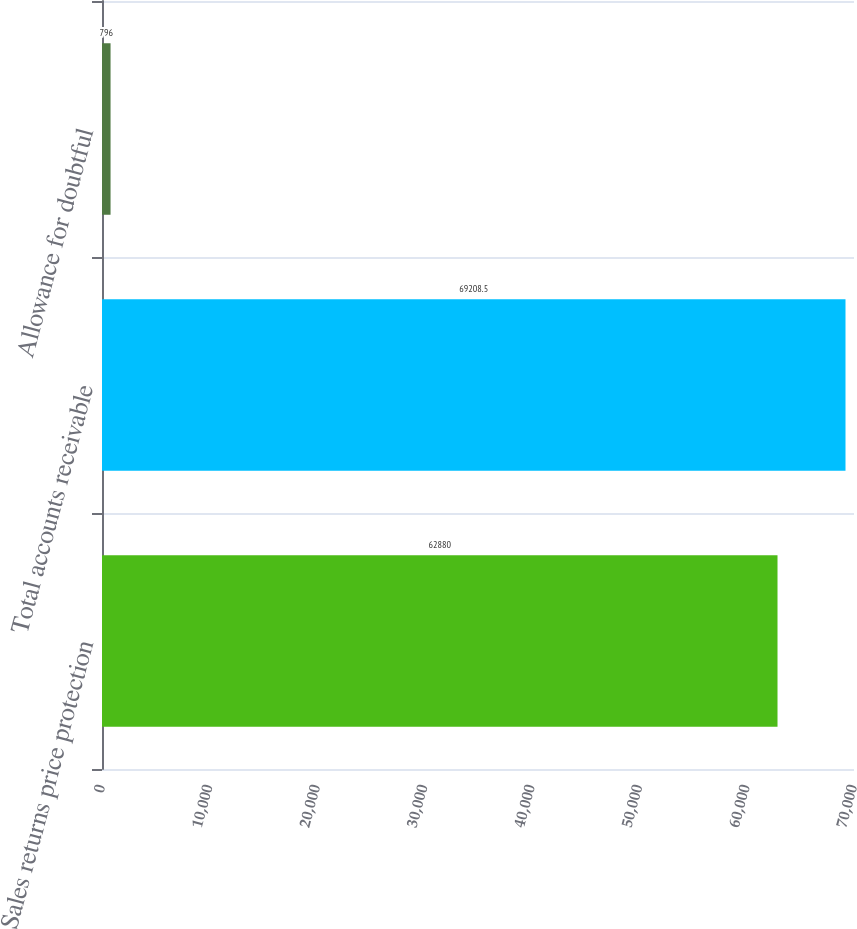Convert chart. <chart><loc_0><loc_0><loc_500><loc_500><bar_chart><fcel>Sales returns price protection<fcel>Total accounts receivable<fcel>Allowance for doubtful<nl><fcel>62880<fcel>69208.5<fcel>796<nl></chart> 